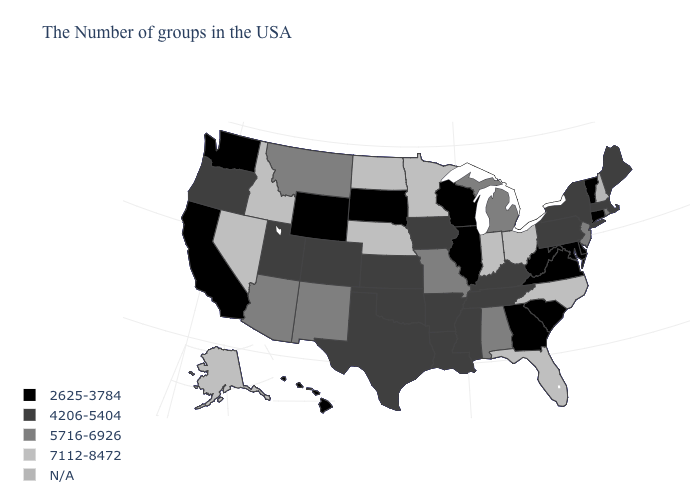What is the value of Nebraska?
Keep it brief. 7112-8472. What is the value of Alabama?
Keep it brief. 5716-6926. What is the lowest value in the West?
Quick response, please. 2625-3784. How many symbols are there in the legend?
Answer briefly. 5. Which states have the lowest value in the MidWest?
Keep it brief. Wisconsin, Illinois, South Dakota. What is the value of Pennsylvania?
Write a very short answer. 4206-5404. Name the states that have a value in the range 7112-8472?
Give a very brief answer. North Carolina, Ohio, Florida, Indiana, Minnesota, Nebraska, North Dakota, Idaho, Nevada, Alaska. Name the states that have a value in the range 7112-8472?
Answer briefly. North Carolina, Ohio, Florida, Indiana, Minnesota, Nebraska, North Dakota, Idaho, Nevada, Alaska. Does the first symbol in the legend represent the smallest category?
Short answer required. Yes. Name the states that have a value in the range 4206-5404?
Concise answer only. Maine, Massachusetts, New York, Pennsylvania, Kentucky, Tennessee, Mississippi, Louisiana, Arkansas, Iowa, Kansas, Oklahoma, Texas, Colorado, Utah, Oregon. Among the states that border Oklahoma , does Missouri have the lowest value?
Short answer required. No. Among the states that border Michigan , which have the lowest value?
Concise answer only. Wisconsin. What is the lowest value in the MidWest?
Keep it brief. 2625-3784. What is the lowest value in the West?
Be succinct. 2625-3784. 